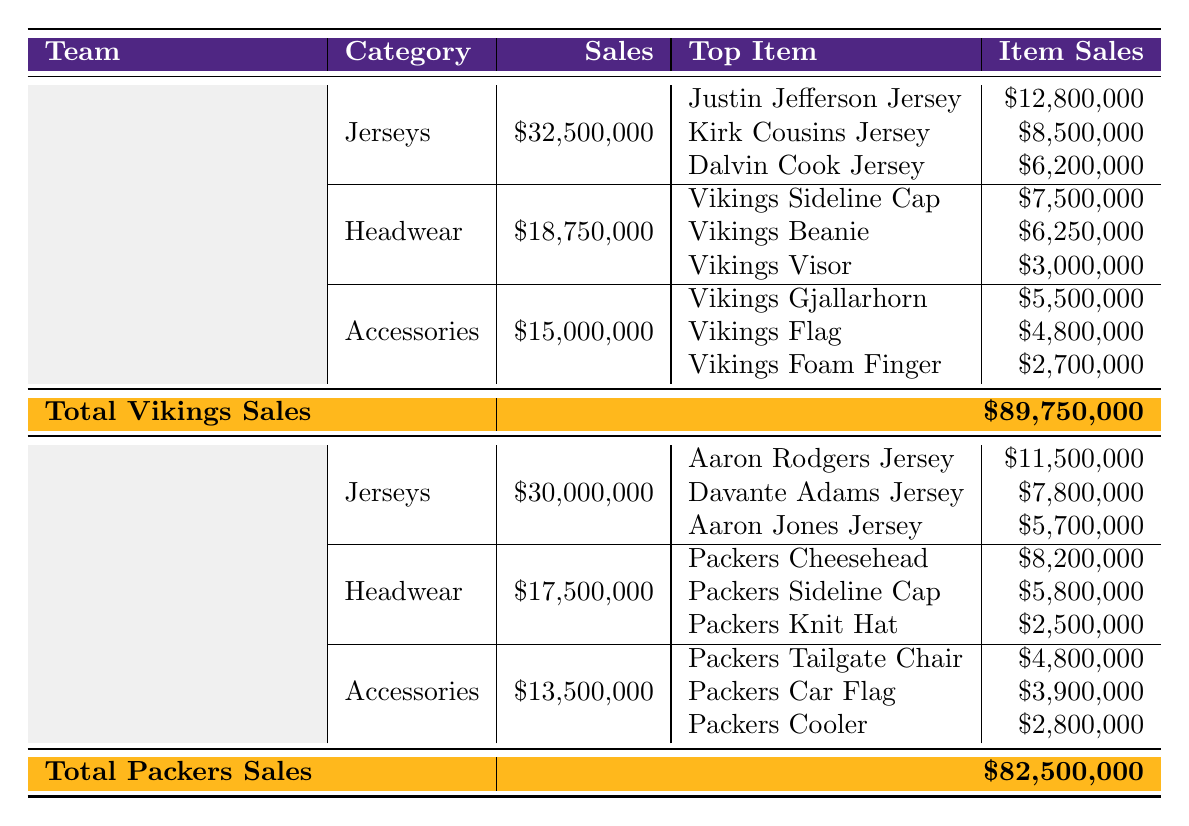What is the total sales for the Minnesota Vikings? The total sales for the Minnesota Vikings is given directly in the table as "$89,750,000."
Answer: $89,750,000 What is the sales amount of the top-selling Jersey for the Green Bay Packers? The top-selling jersey for the Green Bay Packers is the Aaron Rodgers Jersey, which has sales of "$11,500,000."
Answer: $11,500,000 Which team had higher sales in the Accessories category? The Minnesota Vikings have sales of "$15,000,000" for Accessories, while the Green Bay Packers have "$13,500,000." Since $15,000,000 is greater than $13,500,000, the Vikings had higher sales.
Answer: Minnesota Vikings What is the difference in total sales between the two teams? The total sales for the Vikings is "$89,750,000" and for the Packers is "$82,500,000." The difference is $89,750,000 - $82,500,000 = $7,250,000.
Answer: $7,250,000 Which category had the highest sales for the Vikings? The categories are Jerseys ($32,500,000), Headwear ($18,750,000), and Accessories ($15,000,000). Jerseys has the highest sales amount.
Answer: Jerseys Is the sales of the Packers Cheesehead more than the sales of the Vikings Sideline Cap? The Packers Cheesehead sold for "$8,200,000" and the Vikings Sideline Cap sold for "$7,500,000." Since $8,200,000 is greater than $7,500,000, the Packers Cheesehead has more sales.
Answer: Yes How much did the Vikings spend on Jerseys compared to the total sales of the Packers? The Vikings' sales for Jerseys is "$32,500,000," and the Packers’ total sales is "$82,500,000." The comparison shows the Vikings spent approximately 39.4% of the Packers' total sales on jerseys.
Answer: 39.4% What is the combined sales of the top jersey items for both teams? For the Vikings, the top jersey sales are $12,800,000 (Justin Jefferson) + $8,500,000 (Kirk Cousins) + $6,200,000 (Dalvin Cook) = $27,500,000. For the Packers, it's $11,500,000 (Aaron Rodgers) + $7,800,000 (Davante Adams) + $5,700,000 (Aaron Jones) = $25,000,000. The combined total is $27,500,000 + $25,000,000 = $52,500,000.
Answer: $52,500,000 Which product category contributed the least to total sales for the Vikings? The categories and their sales amounts are Jerseys ($32,500,000), Headwear ($18,750,000), and Accessories ($15,000,000). Accessories has the least sales at $15,000,000.
Answer: Accessories If we consider the top items across all categories, which team has the highest single item sales? The highest single item sales for the Vikings is the Justin Jefferson Jersey at "$12,800,000." For the Packers, it is Aaron Rodgers Jersey at "$11,500,000." Since $12,800,000 is greater than $11,500,000, the Vikings have the highest single item sales.
Answer: Minnesota Vikings 